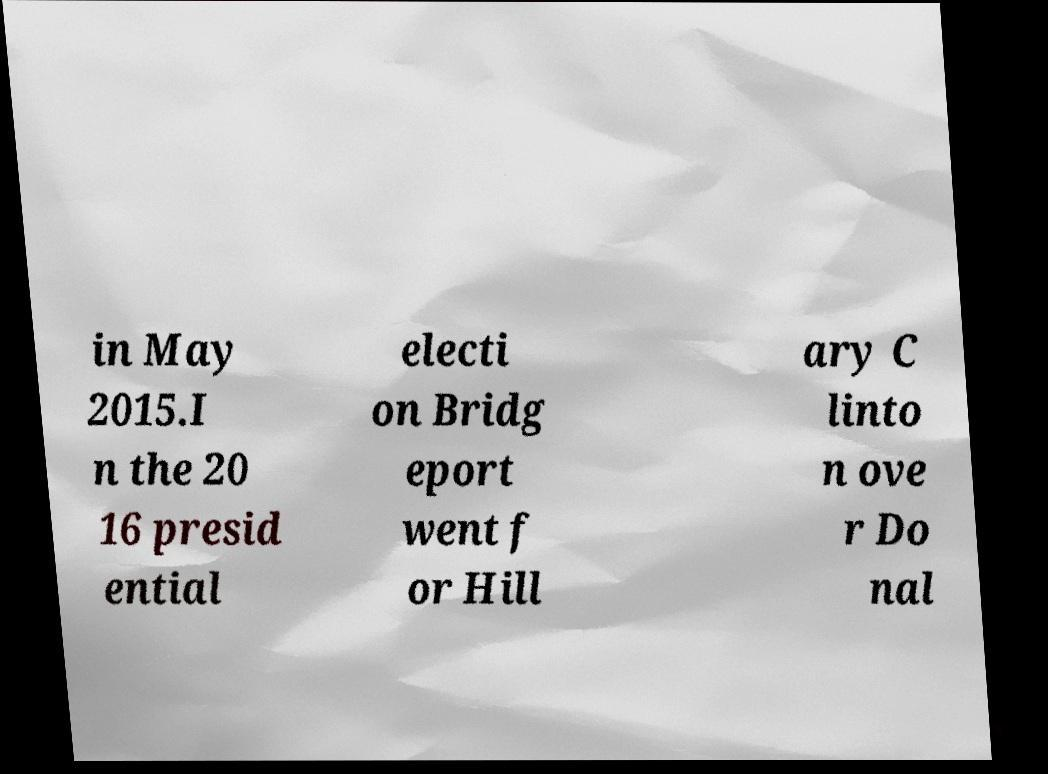Can you accurately transcribe the text from the provided image for me? in May 2015.I n the 20 16 presid ential electi on Bridg eport went f or Hill ary C linto n ove r Do nal 